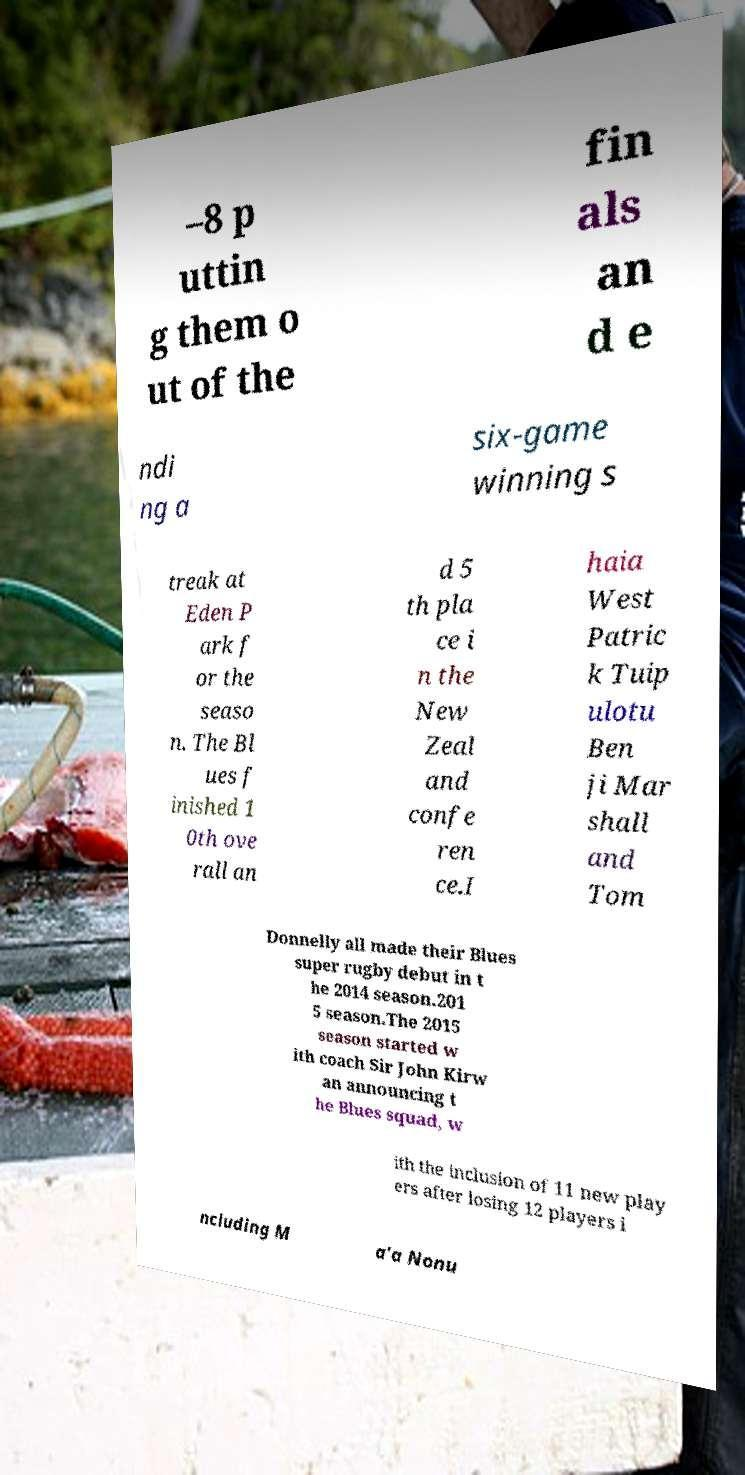Could you assist in decoding the text presented in this image and type it out clearly? –8 p uttin g them o ut of the fin als an d e ndi ng a six-game winning s treak at Eden P ark f or the seaso n. The Bl ues f inished 1 0th ove rall an d 5 th pla ce i n the New Zeal and confe ren ce.I haia West Patric k Tuip ulotu Ben ji Mar shall and Tom Donnelly all made their Blues super rugby debut in t he 2014 season.201 5 season.The 2015 season started w ith coach Sir John Kirw an announcing t he Blues squad, w ith the inclusion of 11 new play ers after losing 12 players i ncluding M a'a Nonu 